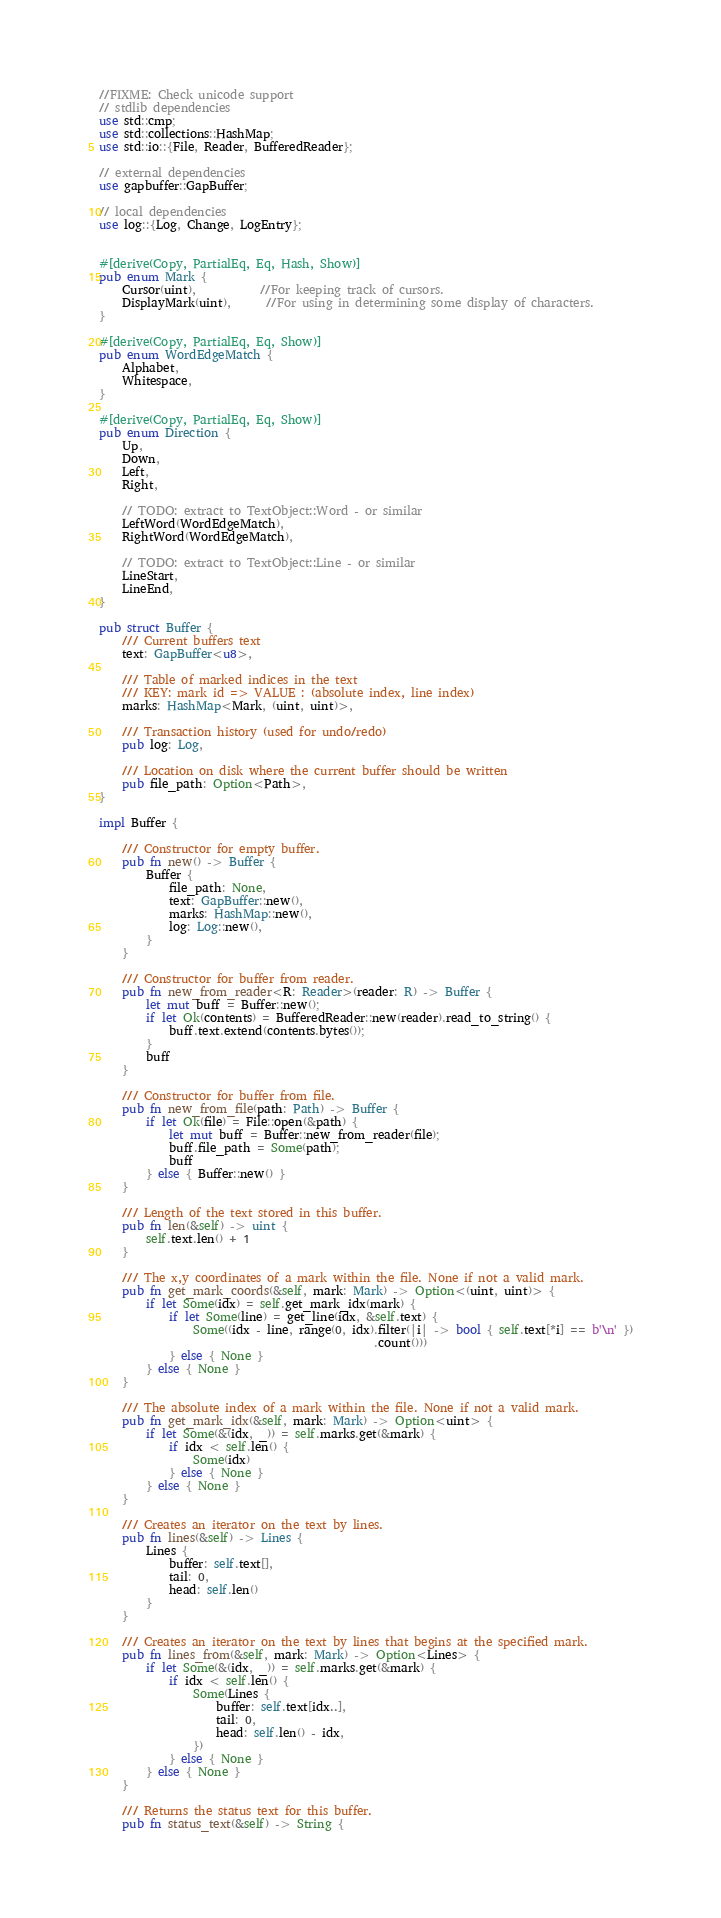Convert code to text. <code><loc_0><loc_0><loc_500><loc_500><_Rust_>//FIXME: Check unicode support
// stdlib dependencies
use std::cmp;
use std::collections::HashMap;
use std::io::{File, Reader, BufferedReader};

// external dependencies
use gapbuffer::GapBuffer;

// local dependencies
use log::{Log, Change, LogEntry};


#[derive(Copy, PartialEq, Eq, Hash, Show)]
pub enum Mark {
    Cursor(uint),           //For keeping track of cursors.
    DisplayMark(uint),      //For using in determining some display of characters.
}

#[derive(Copy, PartialEq, Eq, Show)]
pub enum WordEdgeMatch {
    Alphabet,
    Whitespace,
}

#[derive(Copy, PartialEq, Eq, Show)]
pub enum Direction {
    Up,
    Down,
    Left,
    Right,

    // TODO: extract to TextObject::Word - or similar
    LeftWord(WordEdgeMatch),
    RightWord(WordEdgeMatch),

    // TODO: extract to TextObject::Line - or similar
    LineStart,
    LineEnd,
}

pub struct Buffer {
    /// Current buffers text
    text: GapBuffer<u8>,

    /// Table of marked indices in the text
    /// KEY: mark id => VALUE : (absolute index, line index)
    marks: HashMap<Mark, (uint, uint)>,

    /// Transaction history (used for undo/redo)
    pub log: Log,

    /// Location on disk where the current buffer should be written
    pub file_path: Option<Path>,
}

impl Buffer {

    /// Constructor for empty buffer.
    pub fn new() -> Buffer {
        Buffer {
            file_path: None,
            text: GapBuffer::new(),
            marks: HashMap::new(),
            log: Log::new(),
        }
    }

    /// Constructor for buffer from reader.
    pub fn new_from_reader<R: Reader>(reader: R) -> Buffer {
        let mut buff = Buffer::new();
        if let Ok(contents) = BufferedReader::new(reader).read_to_string() {
            buff.text.extend(contents.bytes());
        }
        buff
    }

    /// Constructor for buffer from file.
    pub fn new_from_file(path: Path) -> Buffer {
        if let Ok(file) = File::open(&path) {
            let mut buff = Buffer::new_from_reader(file);
            buff.file_path = Some(path);
            buff
        } else { Buffer::new() }
    }

    /// Length of the text stored in this buffer.
    pub fn len(&self) -> uint {
        self.text.len() + 1
    }

    /// The x,y coordinates of a mark within the file. None if not a valid mark.
    pub fn get_mark_coords(&self, mark: Mark) -> Option<(uint, uint)> {
        if let Some(idx) = self.get_mark_idx(mark) {
            if let Some(line) = get_line(idx, &self.text) {
                Some((idx - line, range(0, idx).filter(|i| -> bool { self.text[*i] == b'\n' })
                                               .count()))
            } else { None }
        } else { None }
    }

    /// The absolute index of a mark within the file. None if not a valid mark.
    pub fn get_mark_idx(&self, mark: Mark) -> Option<uint> {
        if let Some(&(idx, _)) = self.marks.get(&mark) {
            if idx < self.len() {
                Some(idx)
            } else { None }
        } else { None }
    }

    /// Creates an iterator on the text by lines.
    pub fn lines(&self) -> Lines {
        Lines {
            buffer: self.text[],
            tail: 0,
            head: self.len()
        }
    }

    /// Creates an iterator on the text by lines that begins at the specified mark.
    pub fn lines_from(&self, mark: Mark) -> Option<Lines> {
        if let Some(&(idx, _)) = self.marks.get(&mark) {
            if idx < self.len() {
                Some(Lines {
                    buffer: self.text[idx..],
                    tail: 0,
                    head: self.len() - idx,
                })
            } else { None }
        } else { None }
    }

    /// Returns the status text for this buffer.
    pub fn status_text(&self) -> String {</code> 